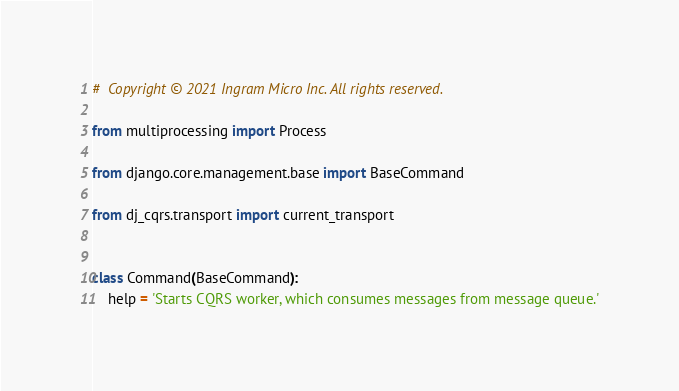Convert code to text. <code><loc_0><loc_0><loc_500><loc_500><_Python_>#  Copyright © 2021 Ingram Micro Inc. All rights reserved.

from multiprocessing import Process

from django.core.management.base import BaseCommand

from dj_cqrs.transport import current_transport


class Command(BaseCommand):
    help = 'Starts CQRS worker, which consumes messages from message queue.'
</code> 